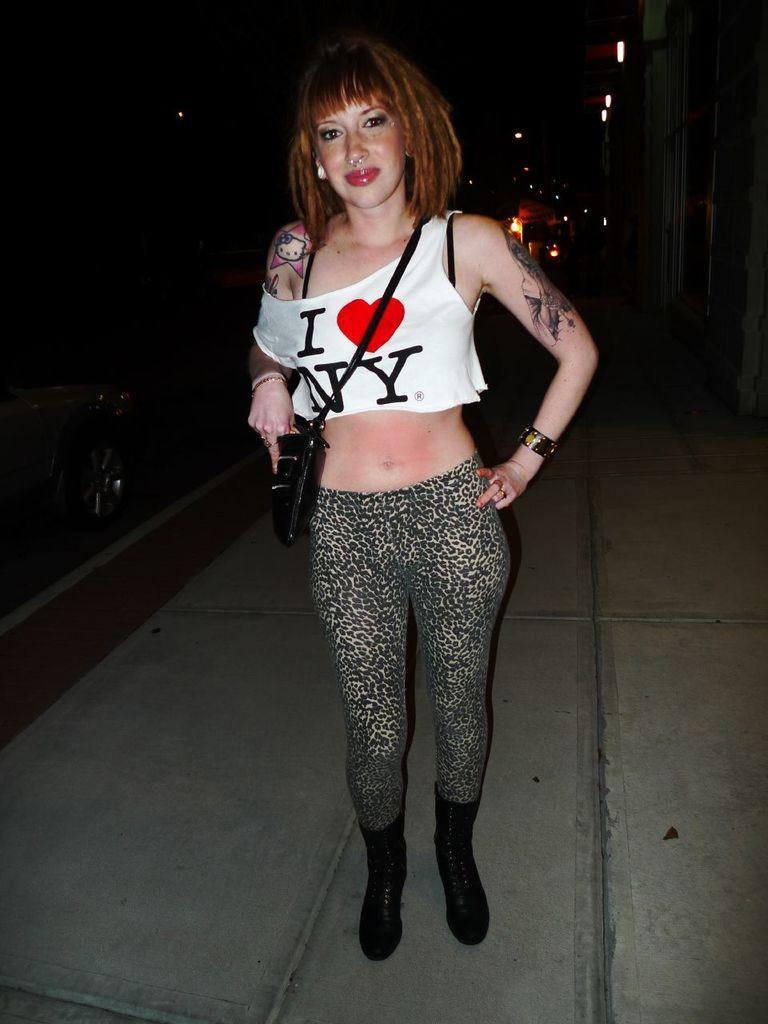Who is the main subject in the image? There is a woman in the image. Where is the woman positioned in the image? The woman is standing in the center of the image. What is the woman doing in the image? The woman is posing for the picture. Can you describe the lighting conditions in the image? The image is taken in the dark. What type of scarf is the woman wearing in the image? There is no scarf visible in the image. Can you see any gravestones or tombstones in the image? The image does not depict a cemetery or any gravestones or tombstones. What is the phase of the moon in the image? The image does not show the moon, so it is not possible to determine its phase. 